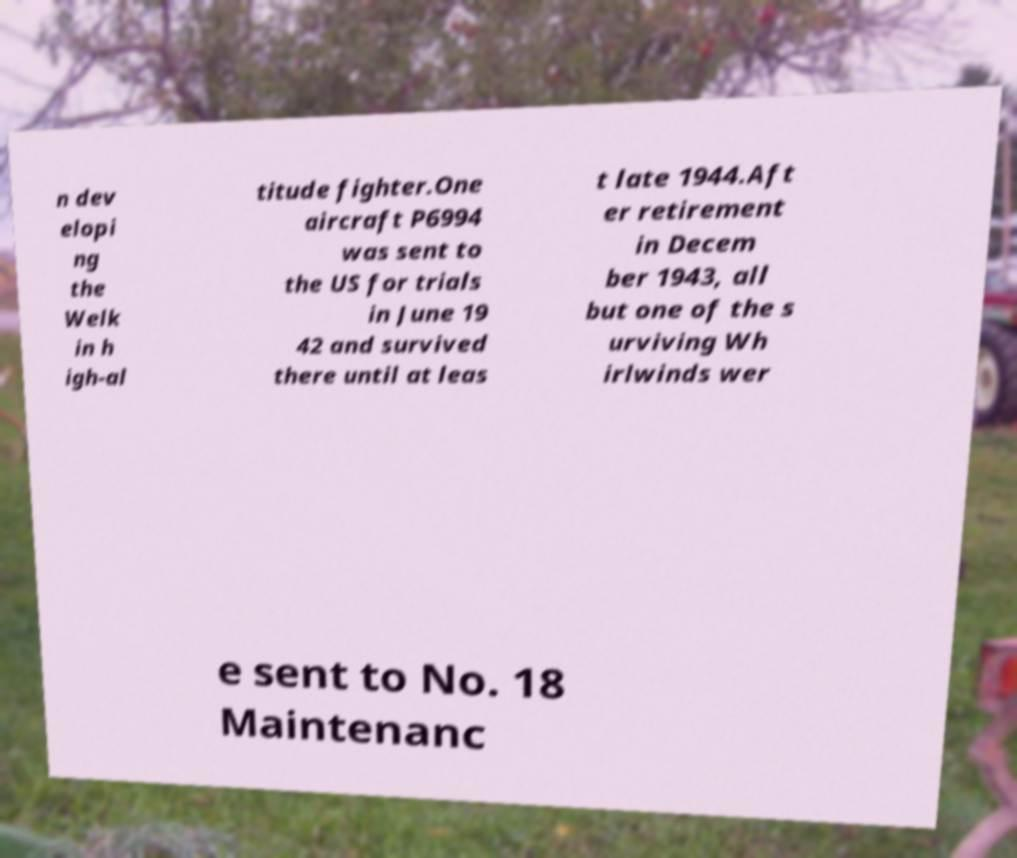Can you read and provide the text displayed in the image?This photo seems to have some interesting text. Can you extract and type it out for me? n dev elopi ng the Welk in h igh-al titude fighter.One aircraft P6994 was sent to the US for trials in June 19 42 and survived there until at leas t late 1944.Aft er retirement in Decem ber 1943, all but one of the s urviving Wh irlwinds wer e sent to No. 18 Maintenanc 